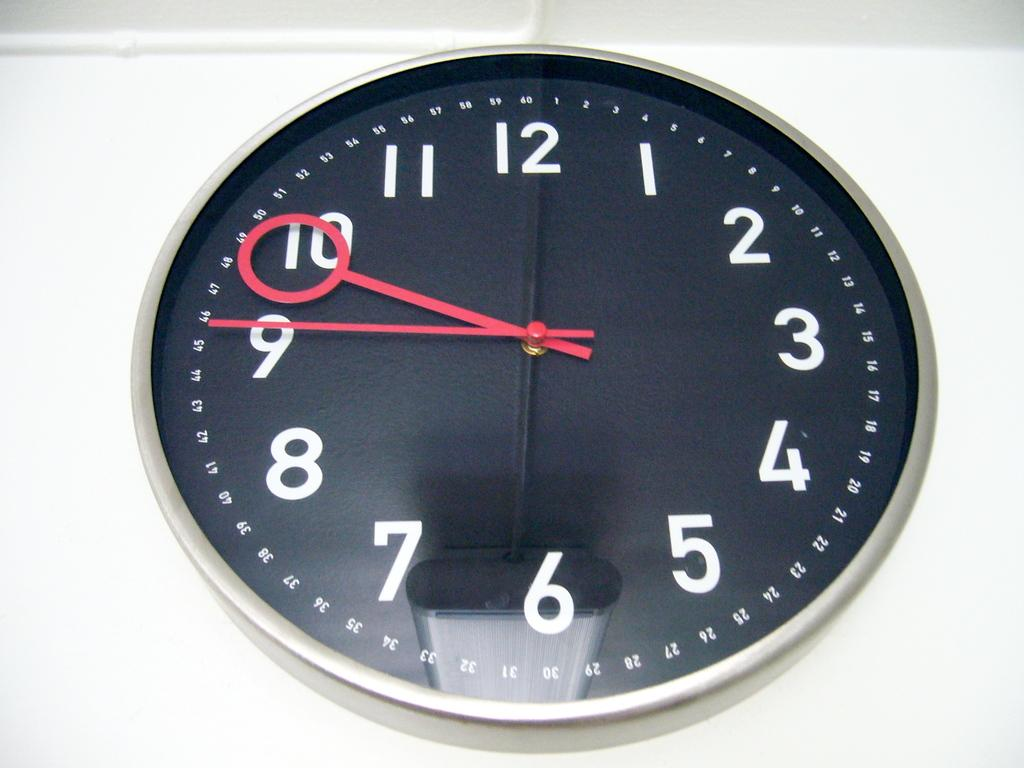<image>
Share a concise interpretation of the image provided. The time on the black and silver clock is 9:46 P.M. 